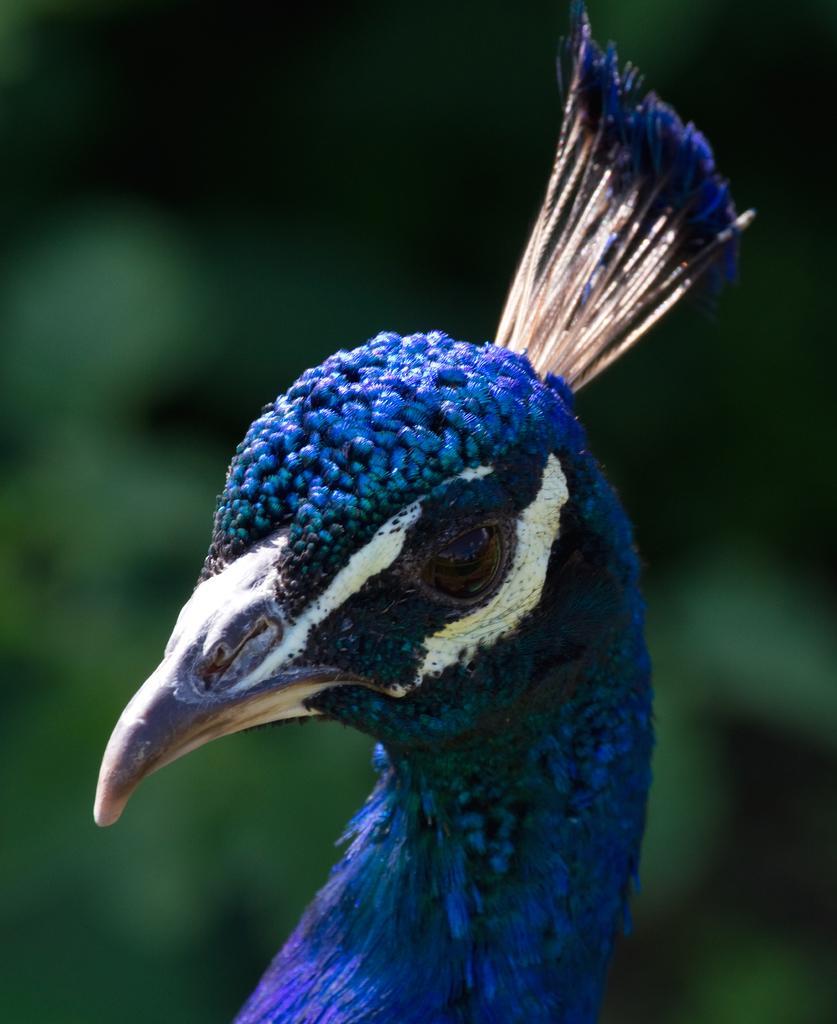Could you give a brief overview of what you see in this image? This image consists of the peacock's head. It has eyes, beak. It is in blue color. 